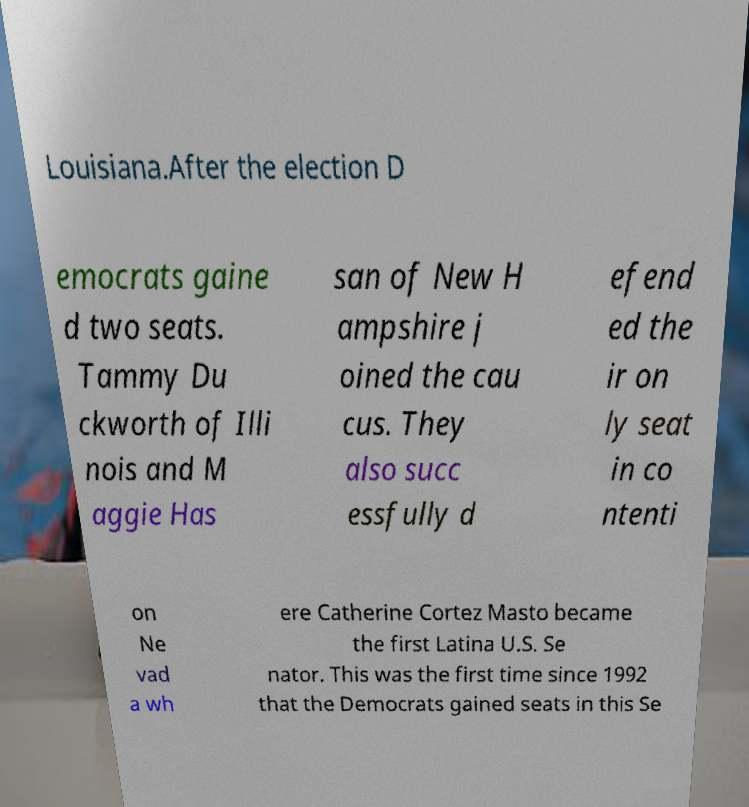Please read and relay the text visible in this image. What does it say? Louisiana.After the election D emocrats gaine d two seats. Tammy Du ckworth of Illi nois and M aggie Has san of New H ampshire j oined the cau cus. They also succ essfully d efend ed the ir on ly seat in co ntenti on Ne vad a wh ere Catherine Cortez Masto became the first Latina U.S. Se nator. This was the first time since 1992 that the Democrats gained seats in this Se 